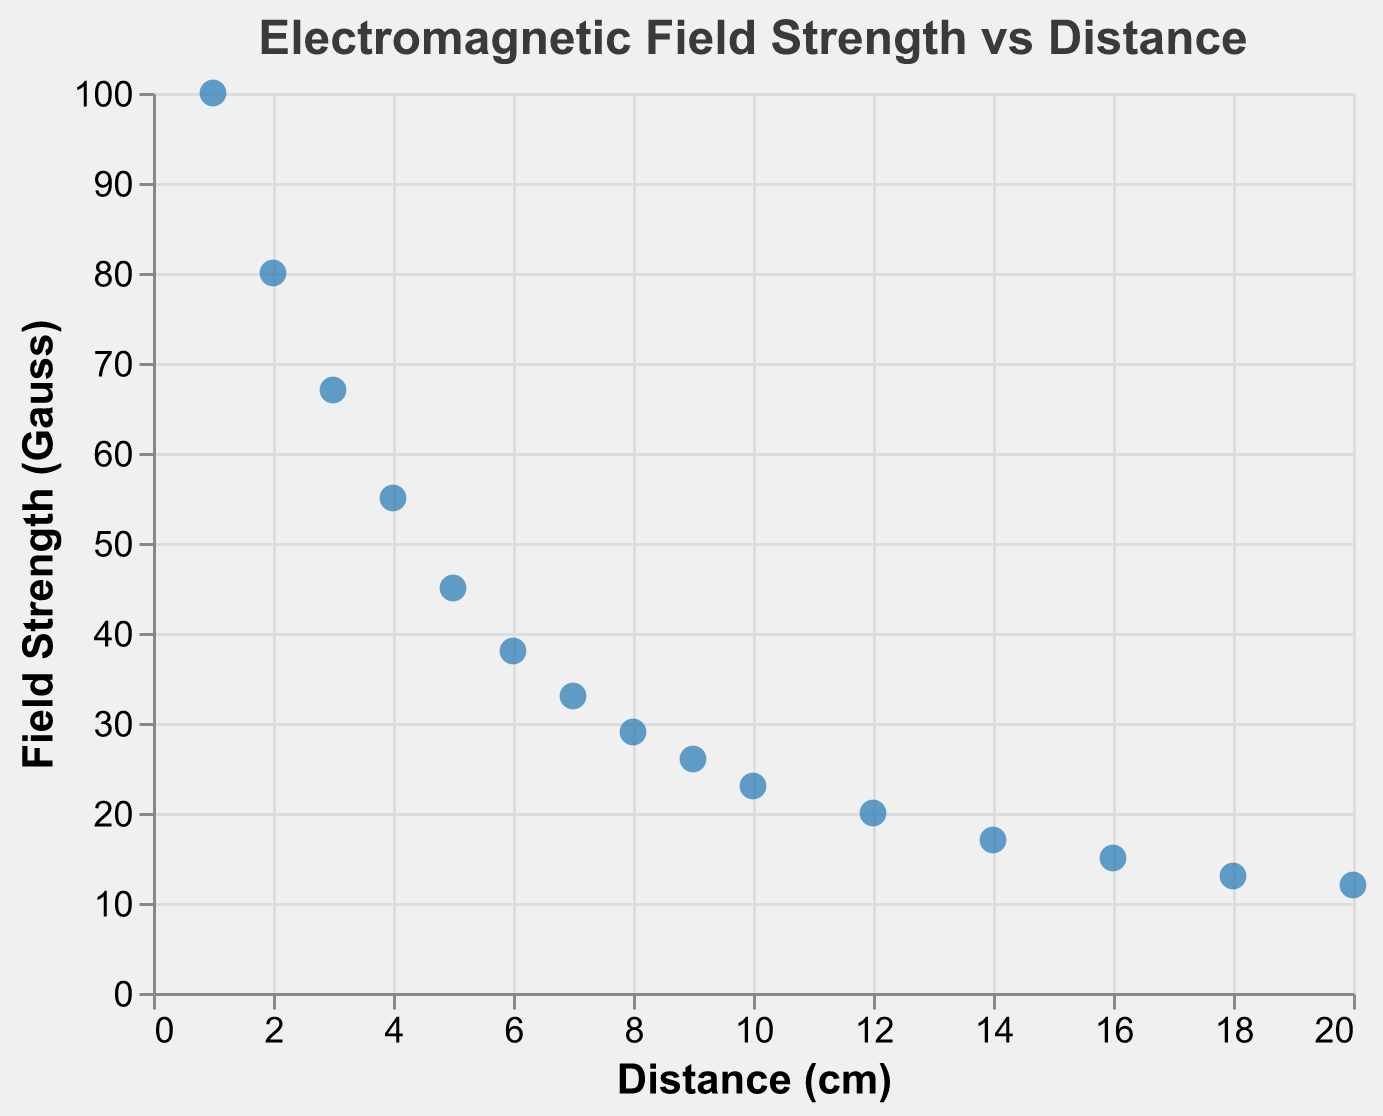What is the title of the figure? The title of the figure is displayed at the top, indicating the relationship being visualized.
Answer: Electromagnetic Field Strength vs Distance How many data points are displayed in the figure? By counting the distinct points on the scatter plot, which represent each pair of distance and field strength values.
Answer: 15 What is the field strength at 10 cm? Locate the point on the graph where the x-axis value is 10 cm and read the corresponding y-axis value.
Answer: 23 Gauss At which distance does the field strength drop below 20 Gauss for the first time? Identify the point on the scatter plot where the y-axis value first falls below 20 Gauss and note the corresponding x-axis value.
Answer: 12 cm What is the difference in field strength between 1 cm and 5 cm? Find the field strength values at 1 cm and 5 cm on the y-axis, subtract the latter from the former (100 - 45).
Answer: 55 Gauss Is the relationship between distance and field strength positive or negative? Observe the general trend of the data points. If the field strength decreases as distance increases, the relationship is negative.
Answer: Negative What is the average field strength between 1 cm and 5 cm? Add the field strengths for the distances 1 cm to 5 cm and divide by the number of data points (100+80+67+55+45)/5.
Answer: 69.4 Gauss Does the scatter plot indicate a linear or non-linear relationship between distance and field strength? Assess whether the data points approximately form a straight line or curve as the distance increases.
Answer: Non-linear How does the field strength change as distance increases from 1 cm to 20 cm? Observe the pattern of the data points from the smallest to the largest x-axis value to describe how the y-axis values change.
Answer: Decreases At what distance does the field strength drop to approximately 30 Gauss? Locate the point where the y-axis value approximates 30 Gauss and read the corresponding x-axis value.
Answer: 8 cm 